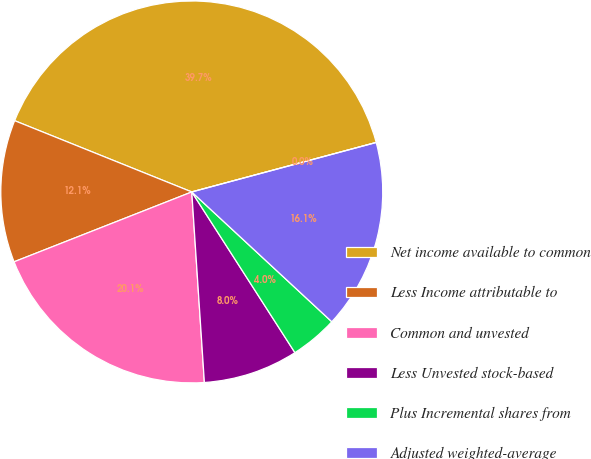<chart> <loc_0><loc_0><loc_500><loc_500><pie_chart><fcel>Net income available to common<fcel>Less Income attributable to<fcel>Common and unvested<fcel>Less Unvested stock-based<fcel>Plus Incremental shares from<fcel>Adjusted weighted-average<fcel>Diluted earnings per common<nl><fcel>39.74%<fcel>12.05%<fcel>20.09%<fcel>8.03%<fcel>4.02%<fcel>16.07%<fcel>0.0%<nl></chart> 